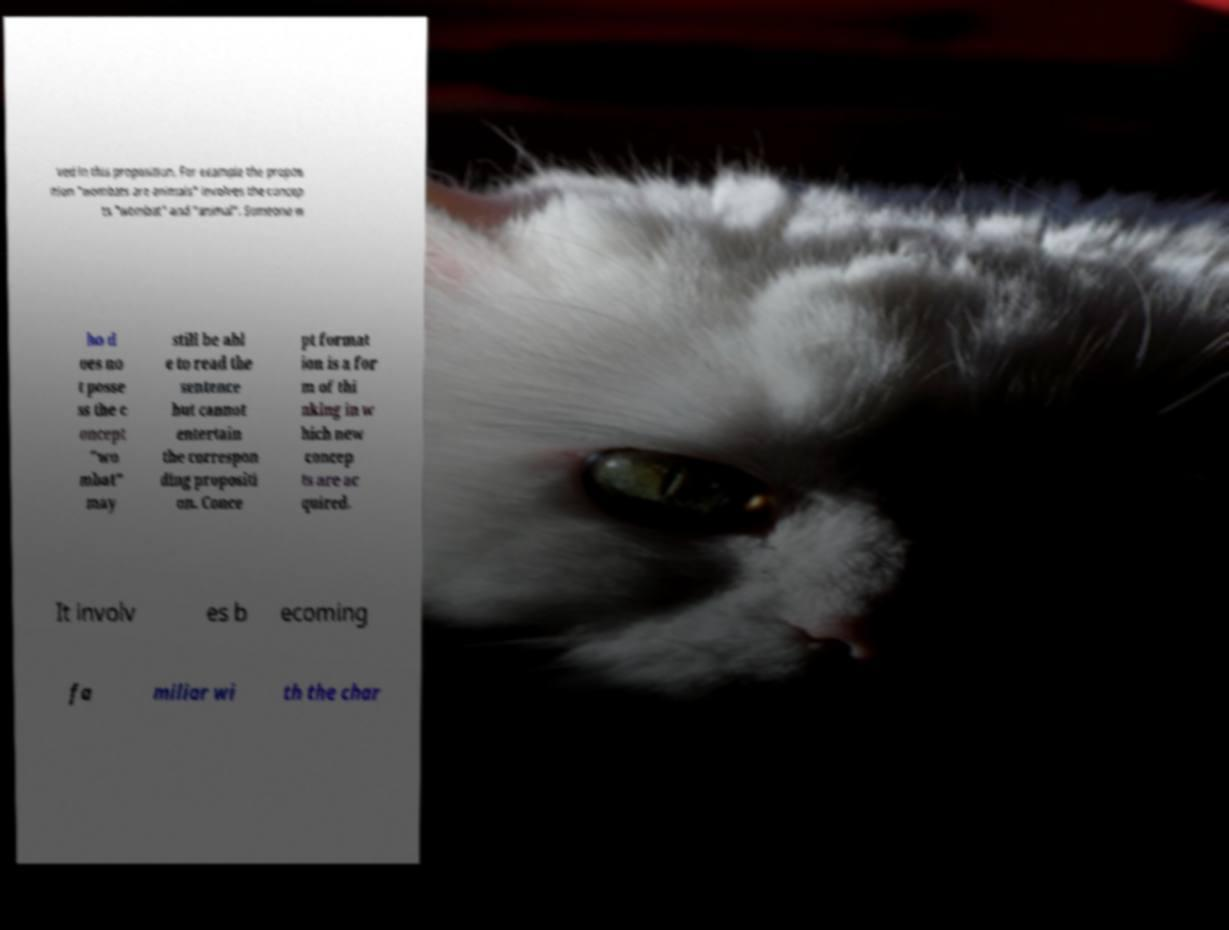Can you accurately transcribe the text from the provided image for me? ved in this proposition. For example the propos ition "wombats are animals" involves the concep ts "wombat" and "animal". Someone w ho d oes no t posse ss the c oncept "wo mbat" may still be abl e to read the sentence but cannot entertain the correspon ding propositi on. Conce pt format ion is a for m of thi nking in w hich new concep ts are ac quired. It involv es b ecoming fa miliar wi th the char 